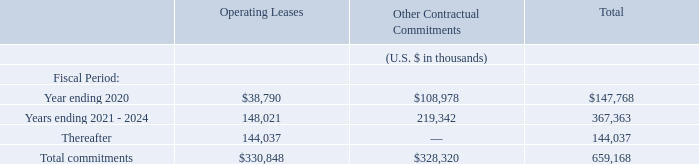18. Commitments
The Group leases various offices in locations such as Amsterdam, the Netherlands; the San Francisco Bay Area, California, New York, New York, Austin, Texas, and Boston, Massachusetts, United States; Sydney, Australia; Manila, the Philippines; Bengaluru, India; Yokohama, Japan; and Ankara, Turkey under non-cancellable operating leases expiring within one to nine years. The leases have varying terms, escalation clauses and renewal rights. On renewal, the terms of the leases are renegotiated. The Group incurred rent expense on its operating leases of $38.6 million, $23.6 million, and $12.2 million during the fiscal years ended 2019, 2018 and 2017, respectively.
Additionally, the Group has a contractual commitment for services with third-parties related to its cloud services platform and data centers. These commitments are non-cancellable and expire within two to four years.
Commitments for minimum lease payments in relation to non-cancellable operating leases and purchase obligations as of June 30, 2019 were as follows:
What is the value of the incurred rent expense on the Group's operating leases during fiscal years ended 2017, 2018 and 2019 respectively?  $12.2 million, $23.6 million, $38.6 million. What are the total commitments towards operating leases?
Answer scale should be: thousand. $330,848. What are the total commitments towards other contractual commitments?
Answer scale should be: thousand. $328,320. What is the total number of countries that the Group leases offices in? The netherlands##united states##australia##philippines##india##japan##turkey
answer: 7. What is the difference in the total commitments between that of operating leases and other contractual commitments?
Answer scale should be: thousand. 330,848-328,320
Answer: 2528. What is the percentage constitution of the commitments for operating leases for year ending 2020 among the total commitments for operating leases?
Answer scale should be: percent. 38,790/330,848
Answer: 11.72. 